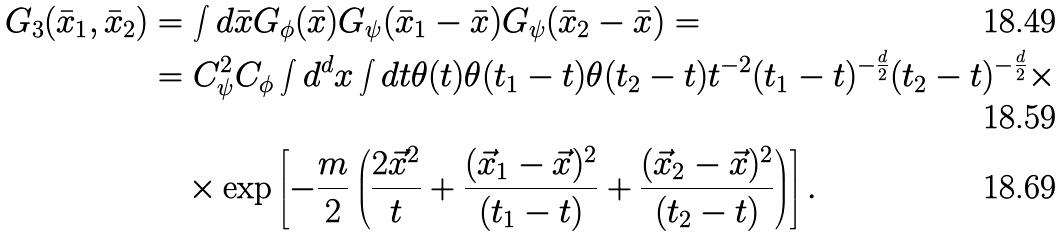Convert formula to latex. <formula><loc_0><loc_0><loc_500><loc_500>G _ { 3 } ( \bar { x } _ { 1 } , \bar { x } _ { 2 } ) & = \int d \bar { x } G _ { \phi } ( \bar { x } ) G _ { \psi } ( \bar { x } _ { 1 } - \bar { x } ) G _ { \psi } ( \bar { x } _ { 2 } - \bar { x } ) = \\ & = C _ { \psi } ^ { 2 } C _ { \phi } \int d ^ { d } x \int d t \theta ( t ) \theta ( t _ { 1 } - t ) \theta ( t _ { 2 } - t ) t ^ { - 2 } ( t _ { 1 } - t ) ^ { - \frac { d } { 2 } } ( t _ { 2 } - t ) ^ { - \frac { d } { 2 } } \times \\ & \quad \times \exp \left [ - \frac { m } { 2 } \left ( \frac { 2 \vec { x } ^ { 2 } } { t } + \frac { ( \vec { x } _ { 1 } - \vec { x } ) ^ { 2 } } { ( t _ { 1 } - t ) } + \frac { ( \vec { x } _ { 2 } - \vec { x } ) ^ { 2 } } { ( t _ { 2 } - t ) } \right ) \right ] .</formula> 